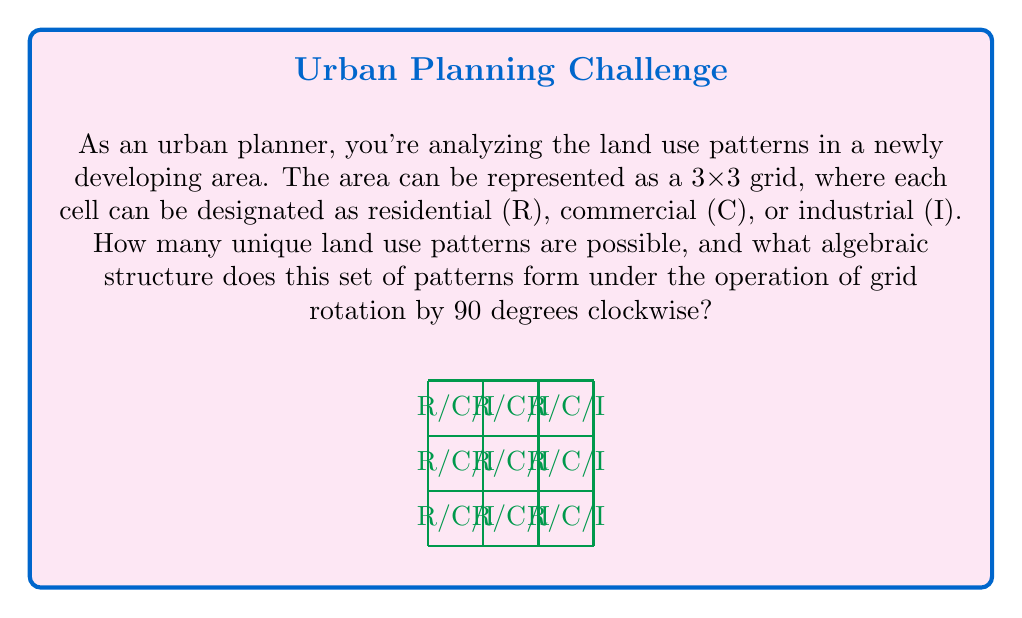Help me with this question. Let's approach this step-by-step:

1) First, let's calculate the total number of possible patterns:
   - Each cell can be R, C, or I
   - There are 9 cells in total
   - So, the total number of patterns is $3^9 = 19,683$

2) Now, let's consider the rotation operation:
   - Rotating the grid by 90 degrees clockwise four times brings us back to the original position
   - This means the rotation operation forms a cyclic group of order 4

3) The set of all patterns forms a set on which this rotation group acts
   - Some patterns will remain unchanged under certain rotations (like a completely uniform grid)
   - Others will change under rotations, forming orbits of size 2 or 4

4) The algebraic structure formed is a group action of the cyclic group $C_4$ on the set of 19,683 patterns

5) To fully describe this structure, we would need to:
   - Identify the patterns that are fixed points under each rotation
   - Count the number of orbits of each size (1, 2, or 4)

6) This structure allows us to study symmetries in land use patterns, which could be valuable for urban planning purposes

7) The complete algebraic description would be:
   $$(C_4, S, \phi)$$
   where $C_4$ is the cyclic group of order 4, $S$ is the set of 19,683 patterns, and $\phi$ is the action of $C_4$ on $S$ defined by rotation
Answer: Group action of $C_4$ on a set of $3^9$ patterns 